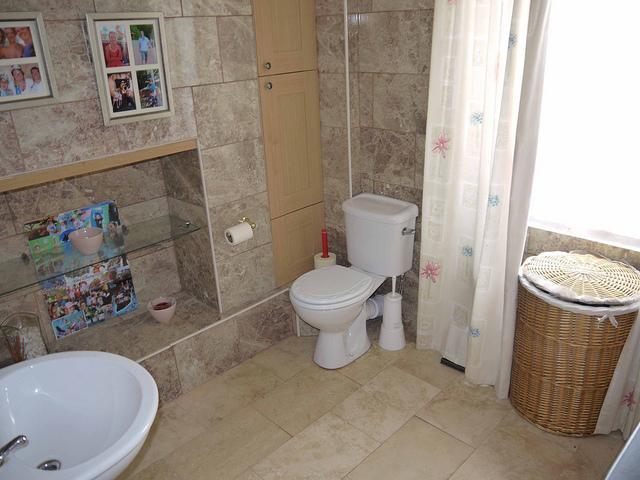How many people are wearing a tie?
Give a very brief answer. 0. 